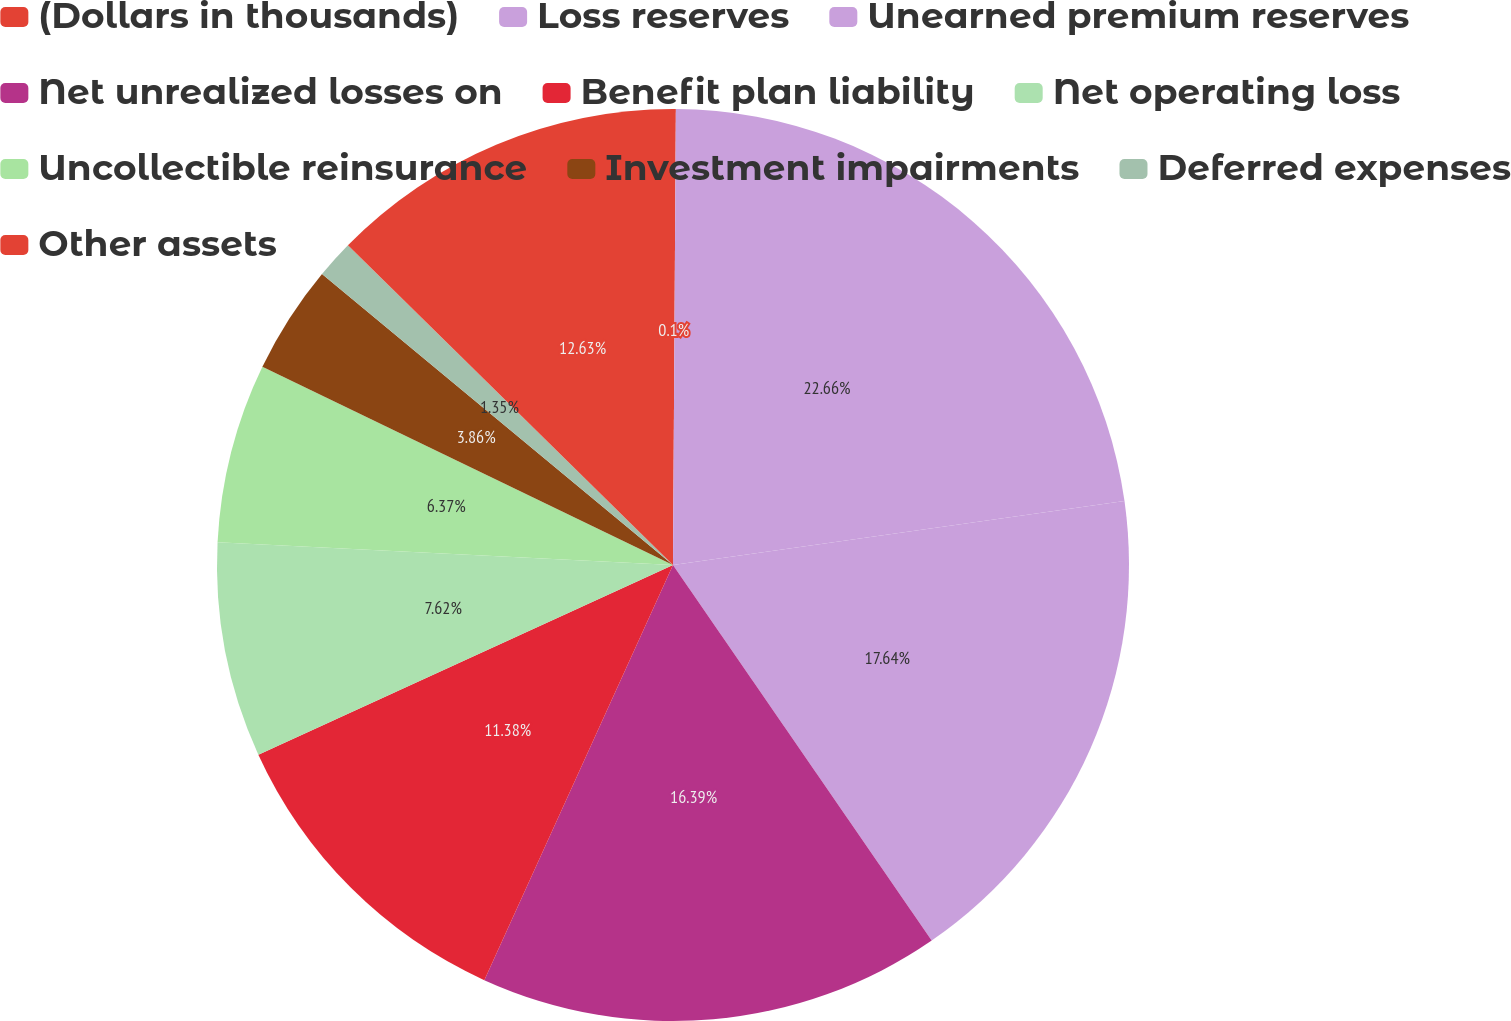Convert chart to OTSL. <chart><loc_0><loc_0><loc_500><loc_500><pie_chart><fcel>(Dollars in thousands)<fcel>Loss reserves<fcel>Unearned premium reserves<fcel>Net unrealized losses on<fcel>Benefit plan liability<fcel>Net operating loss<fcel>Uncollectible reinsurance<fcel>Investment impairments<fcel>Deferred expenses<fcel>Other assets<nl><fcel>0.1%<fcel>22.66%<fcel>17.64%<fcel>16.39%<fcel>11.38%<fcel>7.62%<fcel>6.37%<fcel>3.86%<fcel>1.35%<fcel>12.63%<nl></chart> 